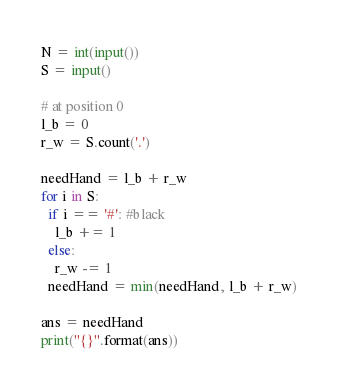<code> <loc_0><loc_0><loc_500><loc_500><_Python_>N = int(input())
S = input()

# at position 0
l_b = 0
r_w = S.count('.')

needHand = l_b + r_w
for i in S:
  if i == '#': #black
    l_b += 1
  else:
    r_w -= 1  
  needHand = min(needHand, l_b + r_w)

ans = needHand
print("{}".format(ans))</code> 